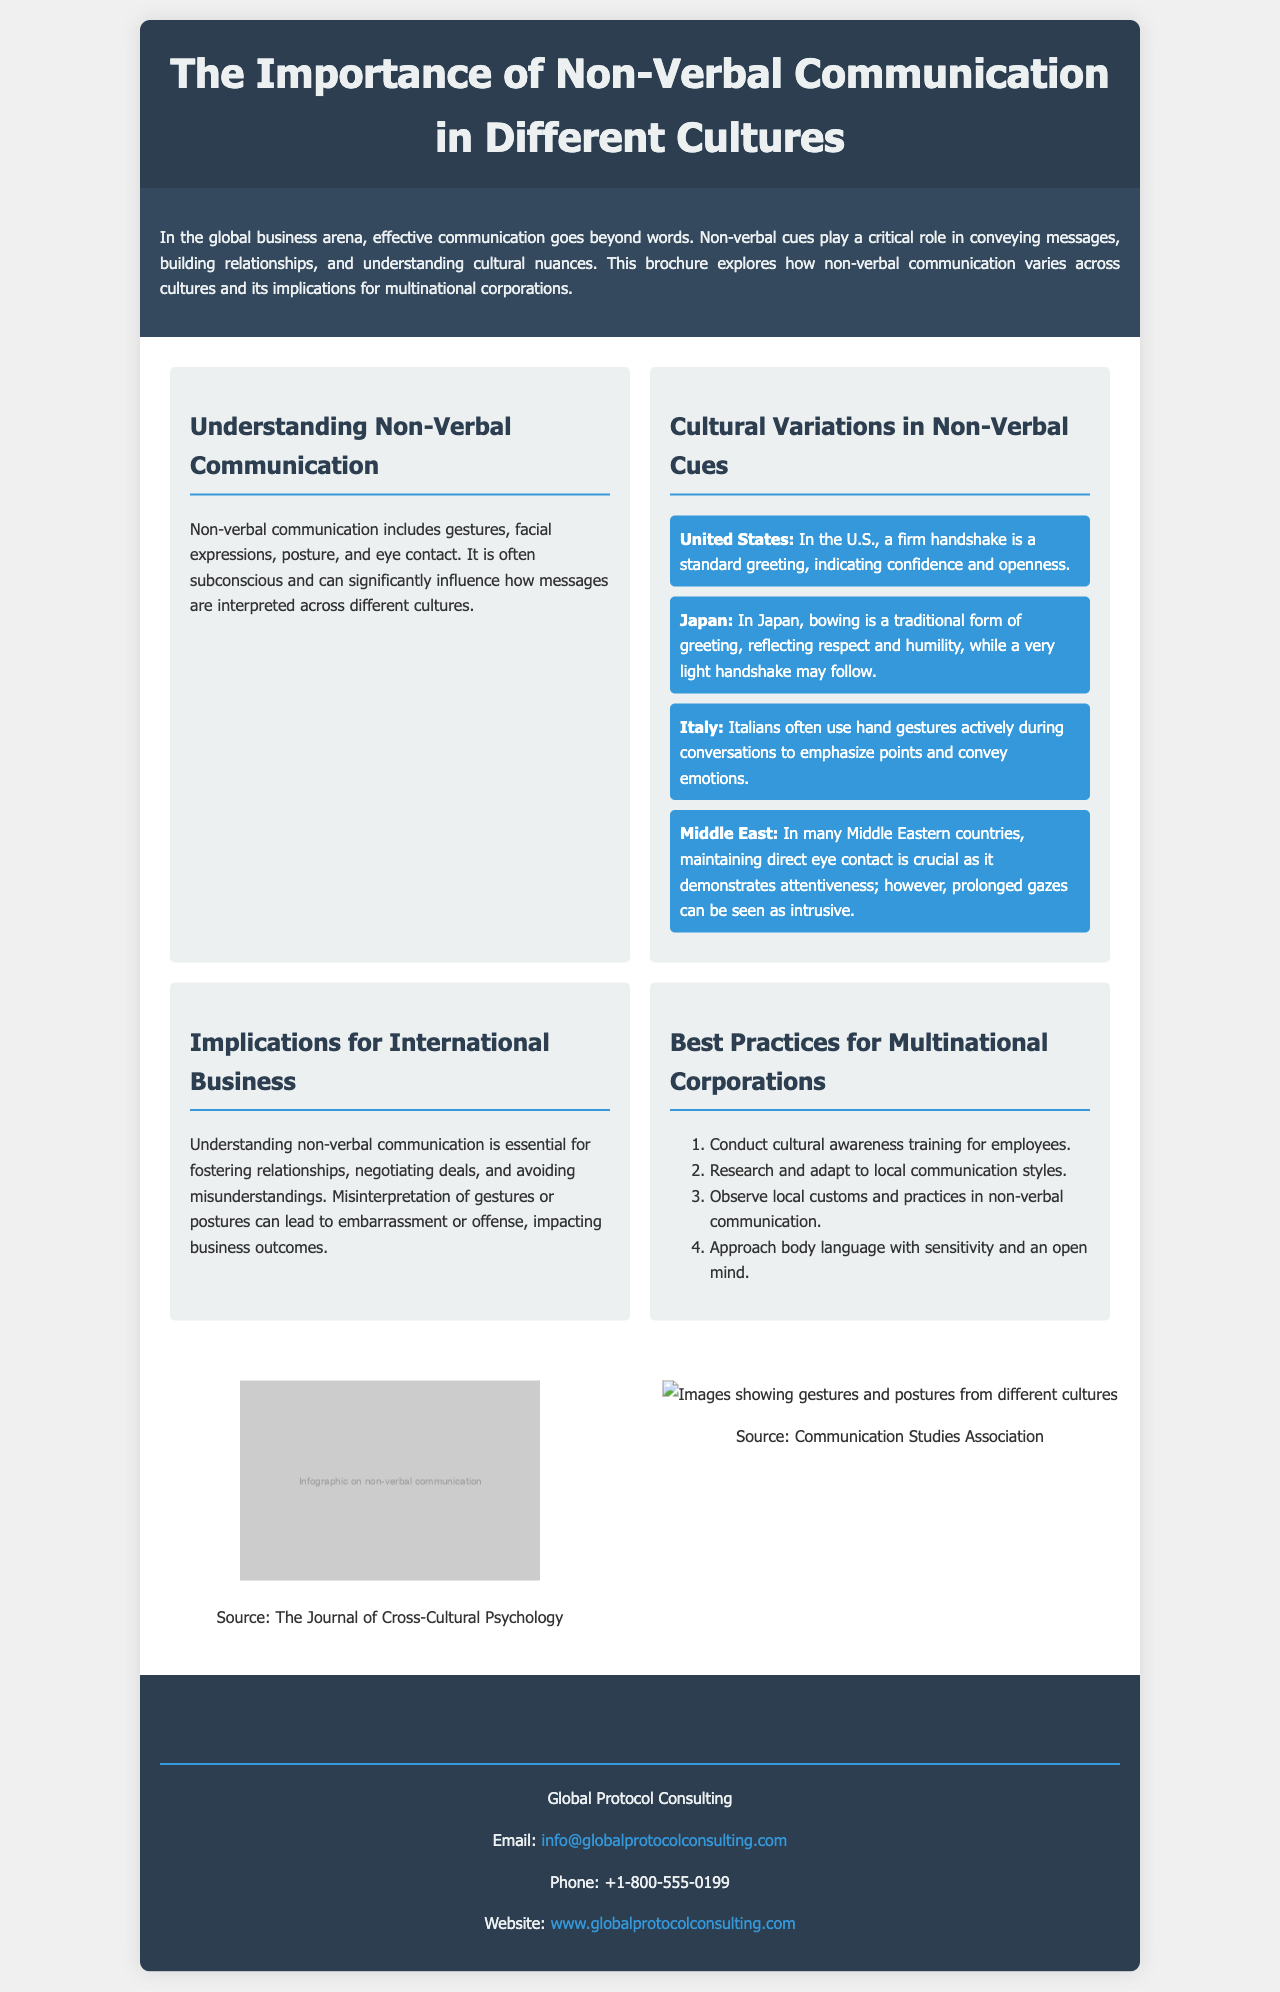What is the title of the brochure? The title is stated prominently in the header of the document.
Answer: The Importance of Non-Verbal Communication in Different Cultures Who is the target audience for this brochure? The brochure is designed for multinational corporations engaged in international business.
Answer: Multinational corporations What gesture is standard in the United States? The brochure mentions a specific gesture representative of the U.S. culture in the section on cultural variations.
Answer: Firm handshake Which culture traditionally uses bowing as a greeting? The brochure provides an example of traditional greetings in different cultures.
Answer: Japan What is one implication for international business mentioned? The brochure outlines a critical consequence of misunderstanding non-verbal cues in the business context.
Answer: Misunderstandings How many best practices are listed for multinational corporations? The document provides a numbered list, making it easy to identify the total number of practices suggested.
Answer: Four What visual aids are included in the brochure? The section on visuals indicates the type of images provided to enhance understanding of the text.
Answer: Infographic and culture gestures images What color is used for the header background? The CSS for the header section specifies its design characteristics, including color.
Answer: Dark blue Who can be contacted for more information? The contact section explicitly provides details for inquiries about the content of the brochure.
Answer: Global Protocol Consulting 